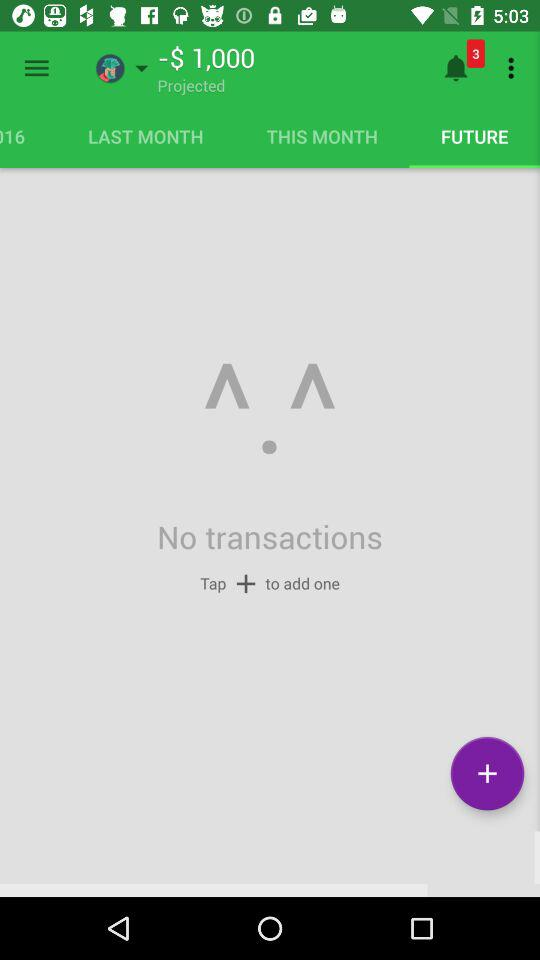How much money is in the budget?
Answer the question using a single word or phrase. -$1,000 